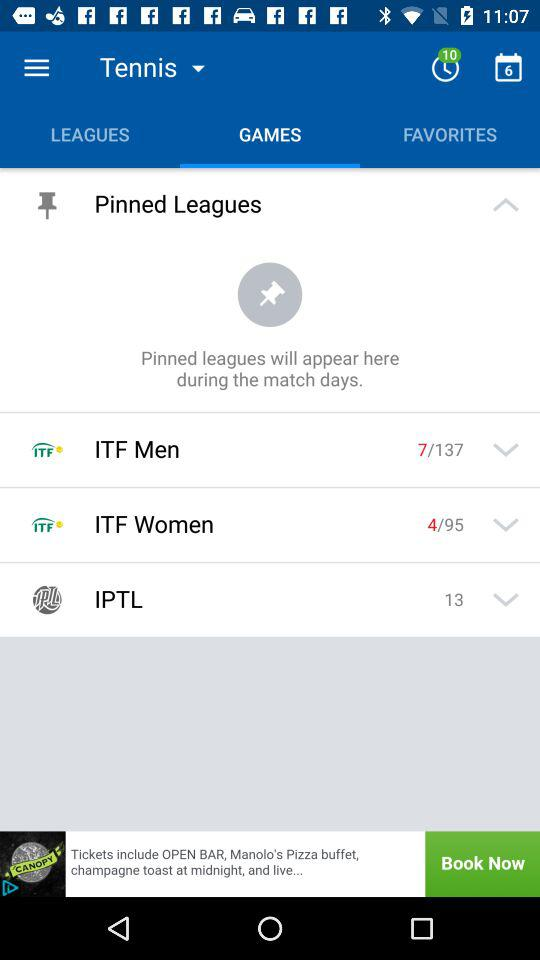What is the selected sport? The selected sport is "Tennis". 